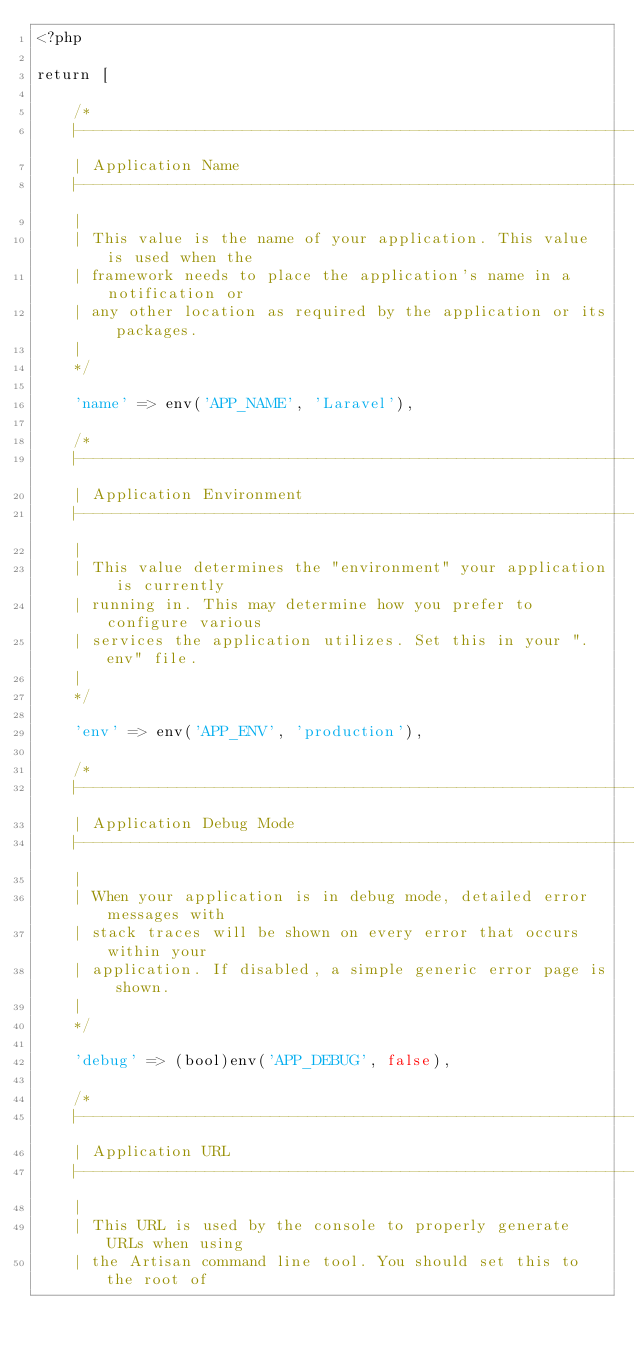<code> <loc_0><loc_0><loc_500><loc_500><_PHP_><?php

return [

    /*
    |--------------------------------------------------------------------------
    | Application Name
    |--------------------------------------------------------------------------
    |
    | This value is the name of your application. This value is used when the
    | framework needs to place the application's name in a notification or
    | any other location as required by the application or its packages.
    |
    */

    'name' => env('APP_NAME', 'Laravel'),

    /*
    |--------------------------------------------------------------------------
    | Application Environment
    |--------------------------------------------------------------------------
    |
    | This value determines the "environment" your application is currently
    | running in. This may determine how you prefer to configure various
    | services the application utilizes. Set this in your ".env" file.
    |
    */

    'env' => env('APP_ENV', 'production'),

    /*
    |--------------------------------------------------------------------------
    | Application Debug Mode
    |--------------------------------------------------------------------------
    |
    | When your application is in debug mode, detailed error messages with
    | stack traces will be shown on every error that occurs within your
    | application. If disabled, a simple generic error page is shown.
    |
    */

    'debug' => (bool)env('APP_DEBUG', false),

    /*
    |--------------------------------------------------------------------------
    | Application URL
    |--------------------------------------------------------------------------
    |
    | This URL is used by the console to properly generate URLs when using
    | the Artisan command line tool. You should set this to the root of</code> 